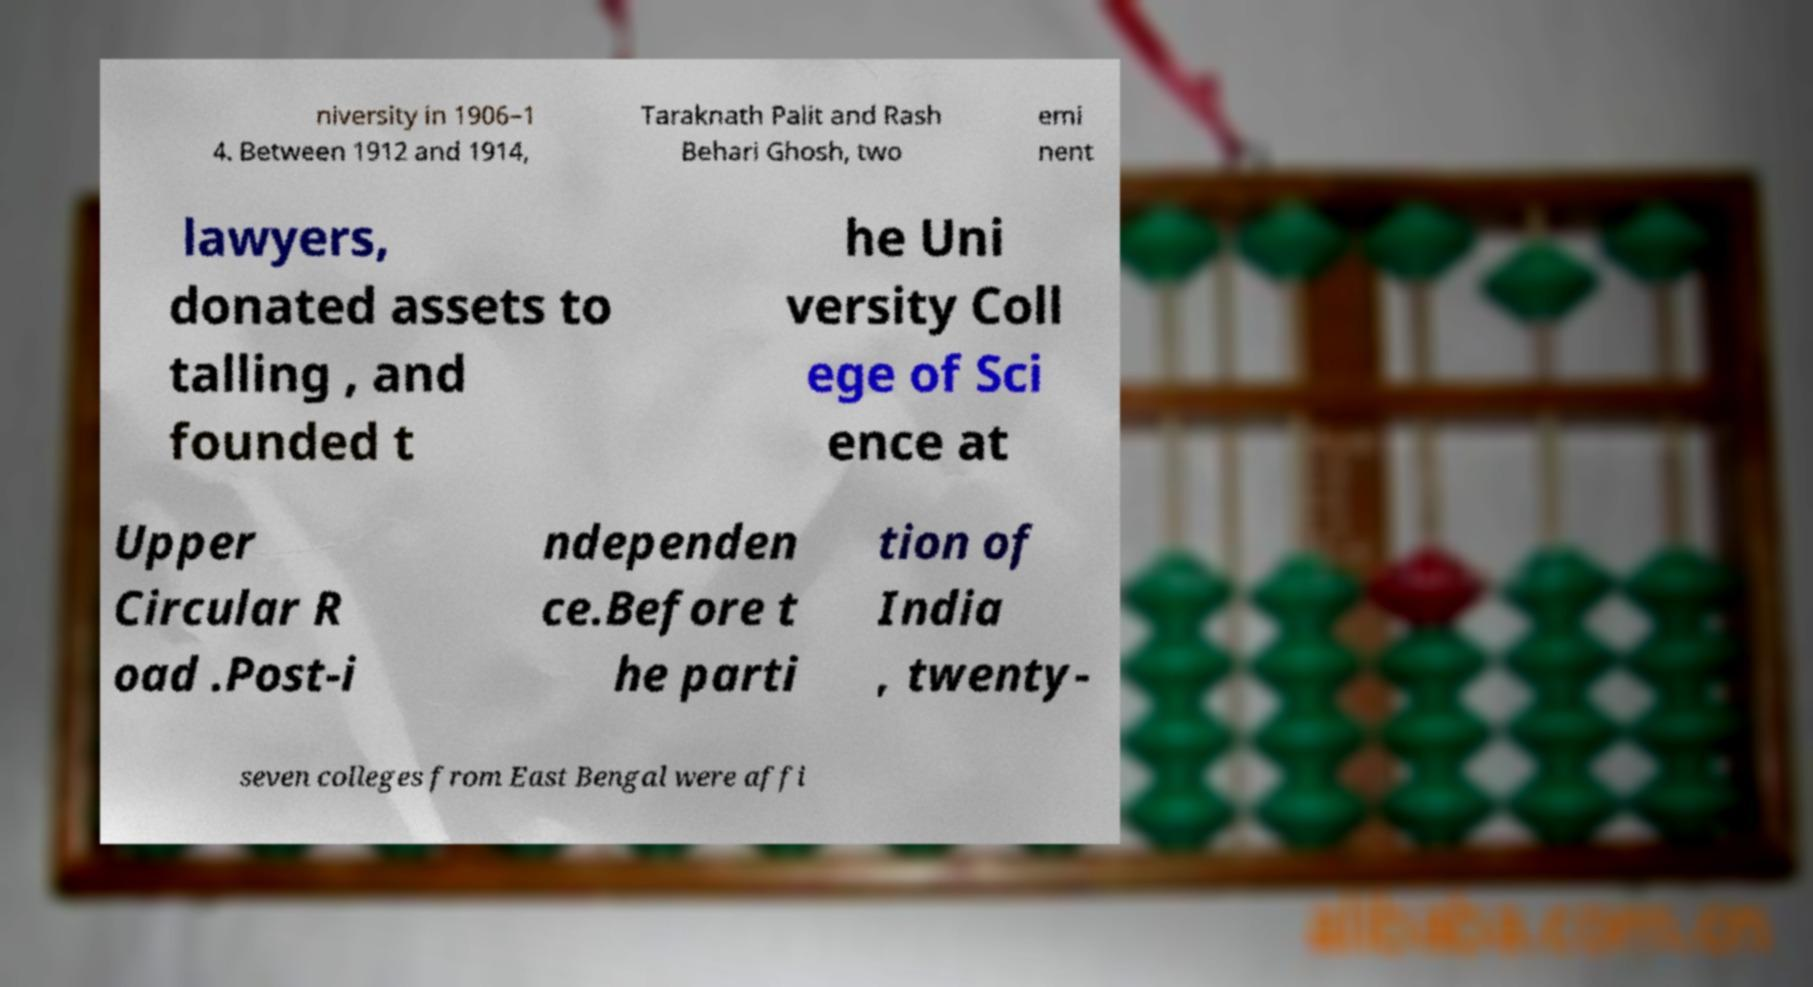Please read and relay the text visible in this image. What does it say? niversity in 1906–1 4. Between 1912 and 1914, Taraknath Palit and Rash Behari Ghosh, two emi nent lawyers, donated assets to talling , and founded t he Uni versity Coll ege of Sci ence at Upper Circular R oad .Post-i ndependen ce.Before t he parti tion of India , twenty- seven colleges from East Bengal were affi 